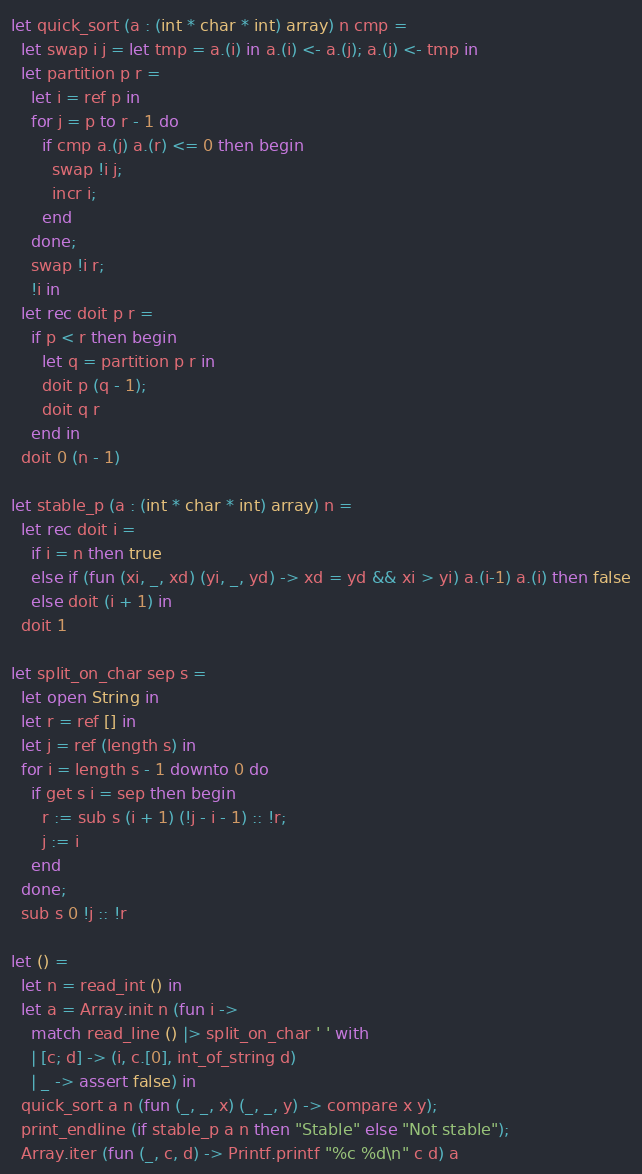Convert code to text. <code><loc_0><loc_0><loc_500><loc_500><_OCaml_>let quick_sort (a : (int * char * int) array) n cmp =
  let swap i j = let tmp = a.(i) in a.(i) <- a.(j); a.(j) <- tmp in
  let partition p r =
    let i = ref p in
    for j = p to r - 1 do
      if cmp a.(j) a.(r) <= 0 then begin
        swap !i j;
        incr i;
      end
    done;
    swap !i r;
    !i in
  let rec doit p r =
    if p < r then begin
      let q = partition p r in
      doit p (q - 1);
      doit q r
    end in
  doit 0 (n - 1)

let stable_p (a : (int * char * int) array) n =
  let rec doit i =
    if i = n then true
    else if (fun (xi, _, xd) (yi, _, yd) -> xd = yd && xi > yi) a.(i-1) a.(i) then false
    else doit (i + 1) in
  doit 1

let split_on_char sep s =
  let open String in
  let r = ref [] in
  let j = ref (length s) in
  for i = length s - 1 downto 0 do
    if get s i = sep then begin
      r := sub s (i + 1) (!j - i - 1) :: !r;
      j := i
    end
  done;
  sub s 0 !j :: !r

let () =
  let n = read_int () in
  let a = Array.init n (fun i ->
    match read_line () |> split_on_char ' ' with
    | [c; d] -> (i, c.[0], int_of_string d)
    | _ -> assert false) in
  quick_sort a n (fun (_, _, x) (_, _, y) -> compare x y);
  print_endline (if stable_p a n then "Stable" else "Not stable");
  Array.iter (fun (_, c, d) -> Printf.printf "%c %d\n" c d) a</code> 